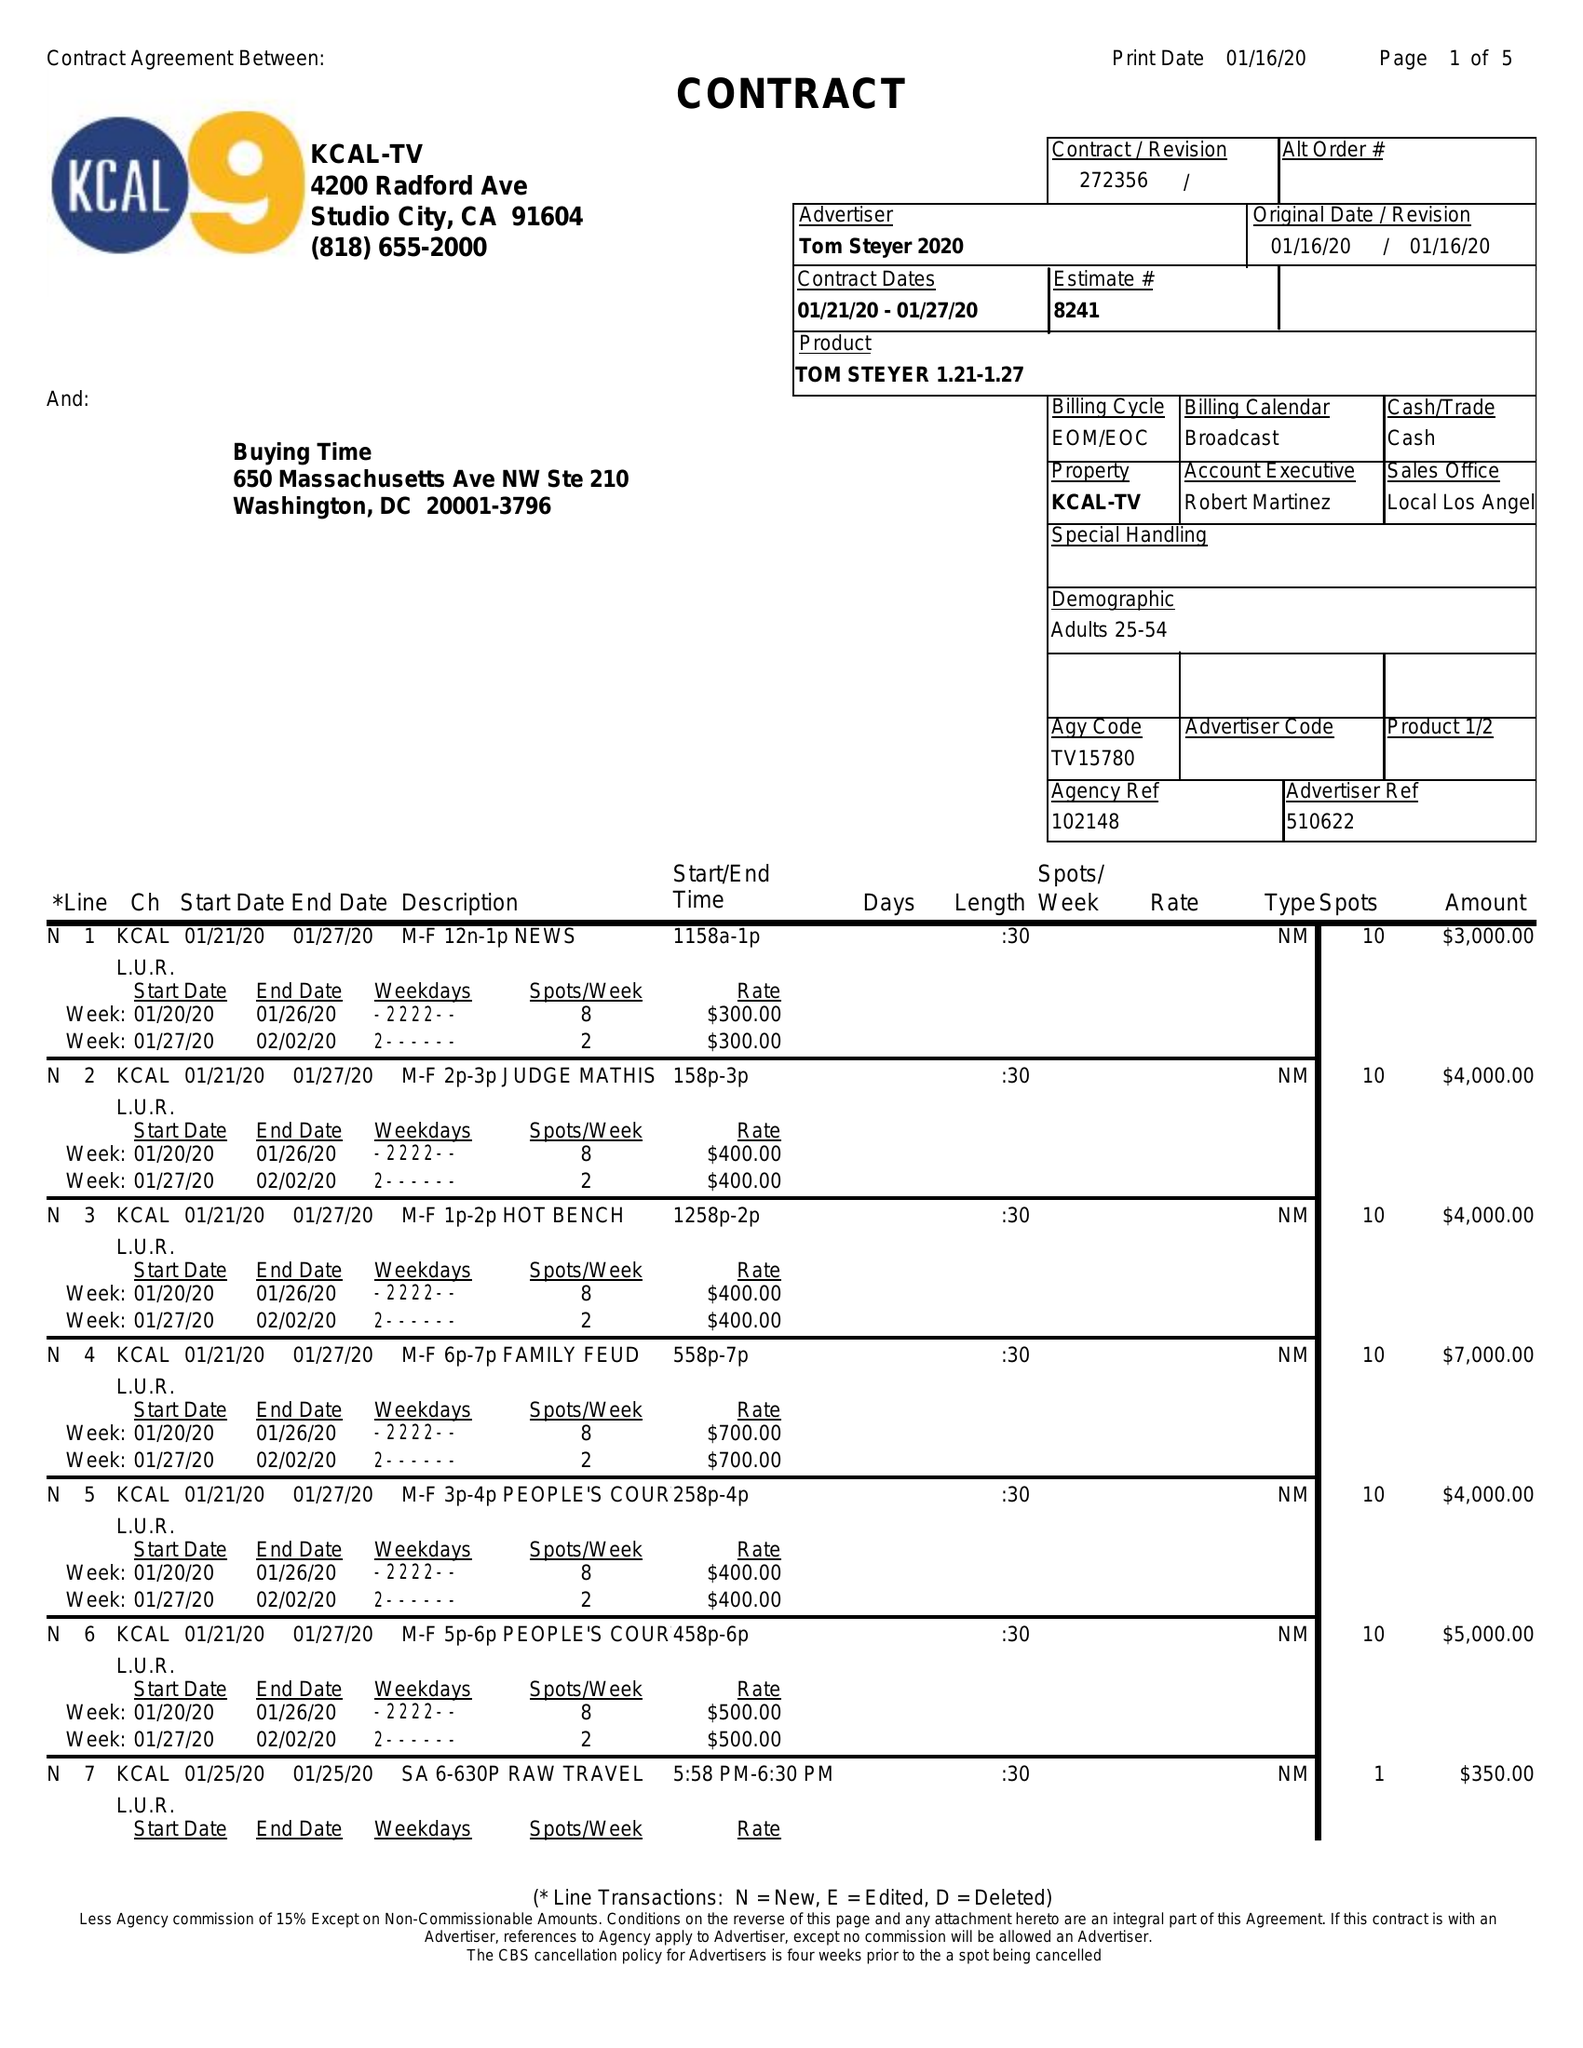What is the value for the advertiser?
Answer the question using a single word or phrase. TOM STEYER 2020 